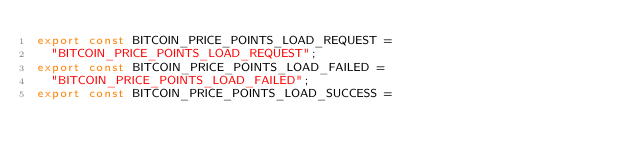Convert code to text. <code><loc_0><loc_0><loc_500><loc_500><_JavaScript_>export const BITCOIN_PRICE_POINTS_LOAD_REQUEST =
  "BITCOIN_PRICE_POINTS_LOAD_REQUEST";
export const BITCOIN_PRICE_POINTS_LOAD_FAILED =
  "BITCOIN_PRICE_POINTS_LOAD_FAILED";
export const BITCOIN_PRICE_POINTS_LOAD_SUCCESS =</code> 